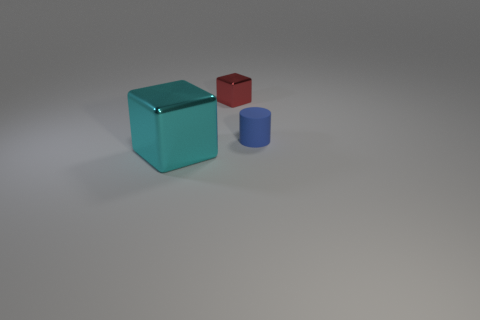Are there any other things that have the same size as the cyan object?
Provide a short and direct response. No. Is there any other thing that has the same material as the tiny block?
Keep it short and to the point. Yes. What is the color of the large metallic object?
Provide a succinct answer. Cyan. Is the tiny matte cylinder the same color as the big shiny block?
Provide a short and direct response. No. There is a metal cube that is in front of the small blue rubber cylinder; how many things are behind it?
Ensure brevity in your answer.  2. There is a thing that is both in front of the small red block and right of the cyan object; what is its size?
Provide a short and direct response. Small. There is a big block that is on the left side of the matte cylinder; what material is it?
Offer a terse response. Metal. Are there any other purple metallic things that have the same shape as the big metallic thing?
Your answer should be very brief. No. What number of blue rubber things are the same shape as the red shiny thing?
Keep it short and to the point. 0. Do the cube that is behind the small blue cylinder and the block that is on the left side of the red metal cube have the same size?
Ensure brevity in your answer.  No. 